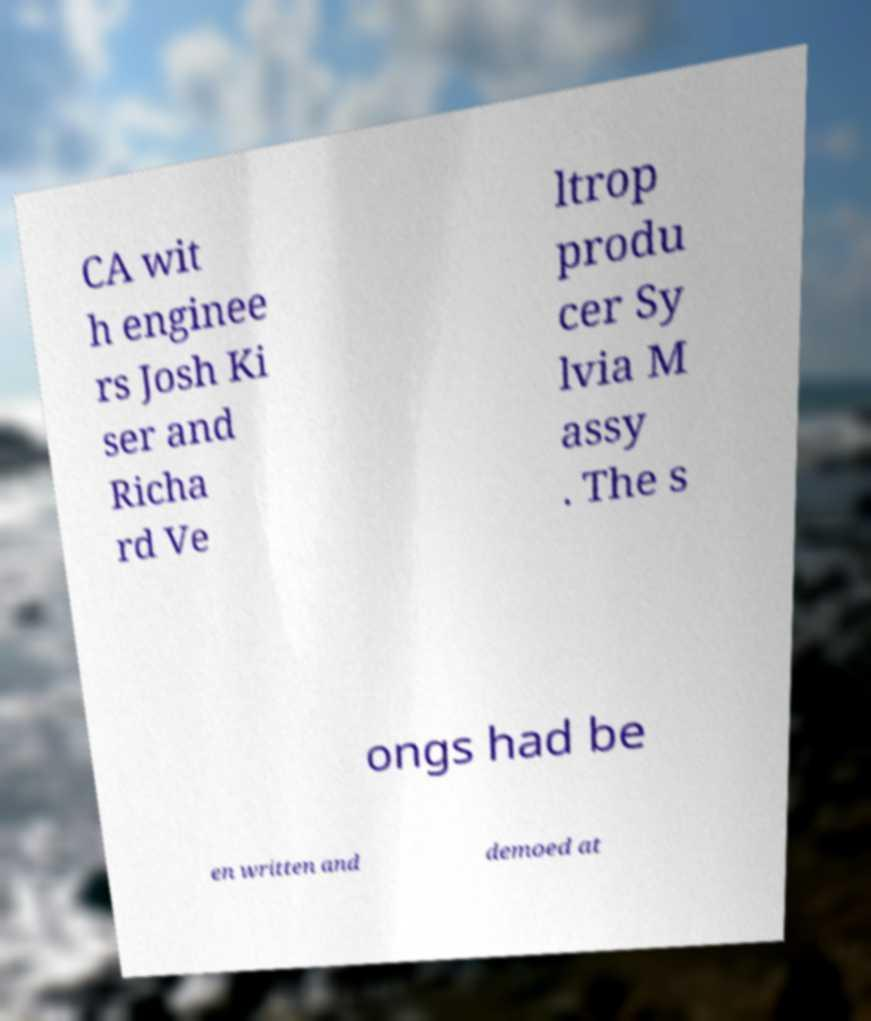For documentation purposes, I need the text within this image transcribed. Could you provide that? CA wit h enginee rs Josh Ki ser and Richa rd Ve ltrop produ cer Sy lvia M assy . The s ongs had be en written and demoed at 